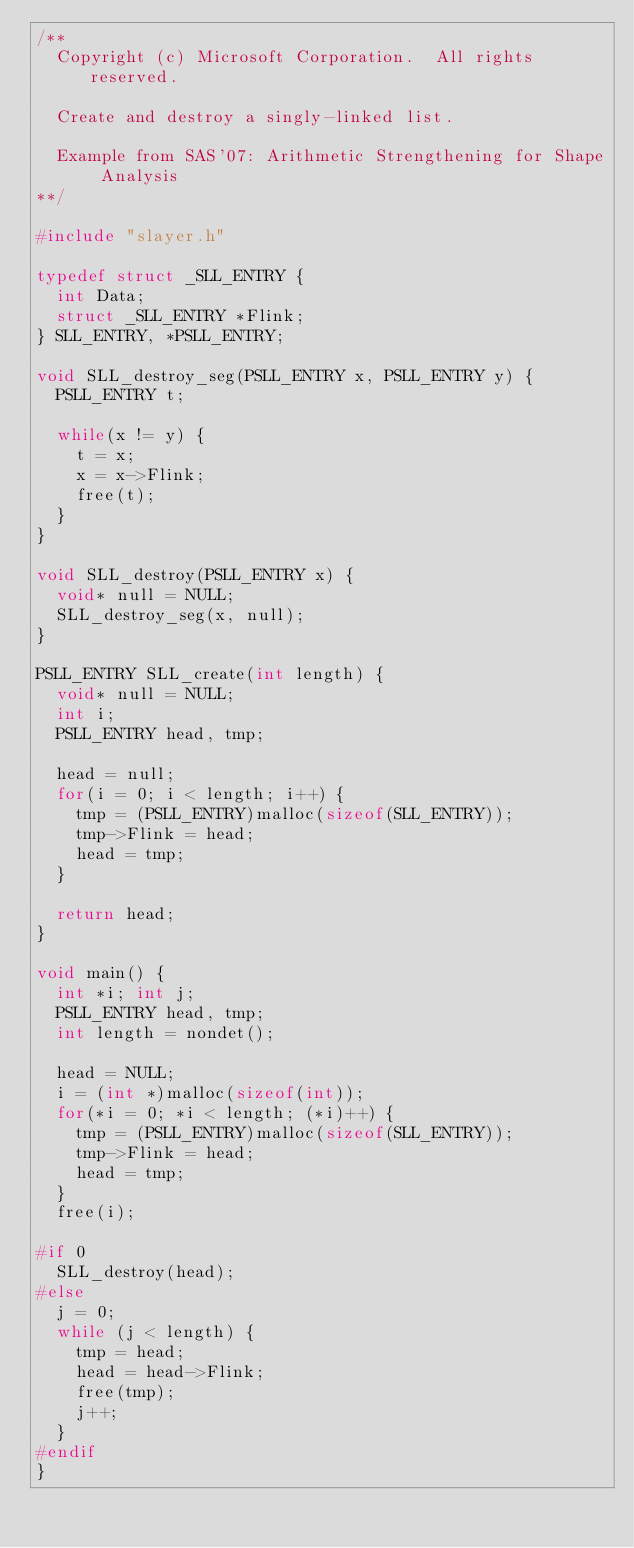Convert code to text. <code><loc_0><loc_0><loc_500><loc_500><_C_>/**
  Copyright (c) Microsoft Corporation.  All rights reserved.

  Create and destroy a singly-linked list.

  Example from SAS'07: Arithmetic Strengthening for Shape Analysis
**/

#include "slayer.h"

typedef struct _SLL_ENTRY {
  int Data;
  struct _SLL_ENTRY *Flink;
} SLL_ENTRY, *PSLL_ENTRY;

void SLL_destroy_seg(PSLL_ENTRY x, PSLL_ENTRY y) {
  PSLL_ENTRY t;

  while(x != y) {
    t = x;
    x = x->Flink;
    free(t);
  }
}

void SLL_destroy(PSLL_ENTRY x) {
  void* null = NULL;
  SLL_destroy_seg(x, null);
}

PSLL_ENTRY SLL_create(int length) {
  void* null = NULL;
  int i;
  PSLL_ENTRY head, tmp;

  head = null;
  for(i = 0; i < length; i++) {
    tmp = (PSLL_ENTRY)malloc(sizeof(SLL_ENTRY));
    tmp->Flink = head;
    head = tmp;
  }

  return head;
}

void main() {
  int *i; int j;
  PSLL_ENTRY head, tmp;
  int length = nondet();

  head = NULL;
  i = (int *)malloc(sizeof(int));
  for(*i = 0; *i < length; (*i)++) {
    tmp = (PSLL_ENTRY)malloc(sizeof(SLL_ENTRY));
    tmp->Flink = head;
    head = tmp;
  }
  free(i);

#if 0
  SLL_destroy(head);
#else
  j = 0;
  while (j < length) {
    tmp = head;
    head = head->Flink;
    free(tmp);
    j++;
  }
#endif
}
</code> 